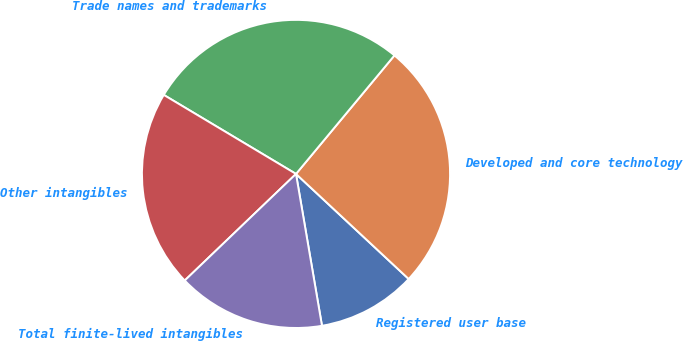Convert chart to OTSL. <chart><loc_0><loc_0><loc_500><loc_500><pie_chart><fcel>Registered user base<fcel>Developed and core technology<fcel>Trade names and trademarks<fcel>Other intangibles<fcel>Total finite-lived intangibles<nl><fcel>10.36%<fcel>25.91%<fcel>27.46%<fcel>20.73%<fcel>15.54%<nl></chart> 